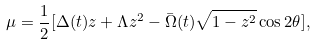<formula> <loc_0><loc_0><loc_500><loc_500>\mu = \frac { 1 } { 2 } [ \Delta ( t ) z + \Lambda z ^ { 2 } - \bar { \Omega } ( t ) \sqrt { 1 - z ^ { 2 } } \cos { 2 \theta } ] ,</formula> 